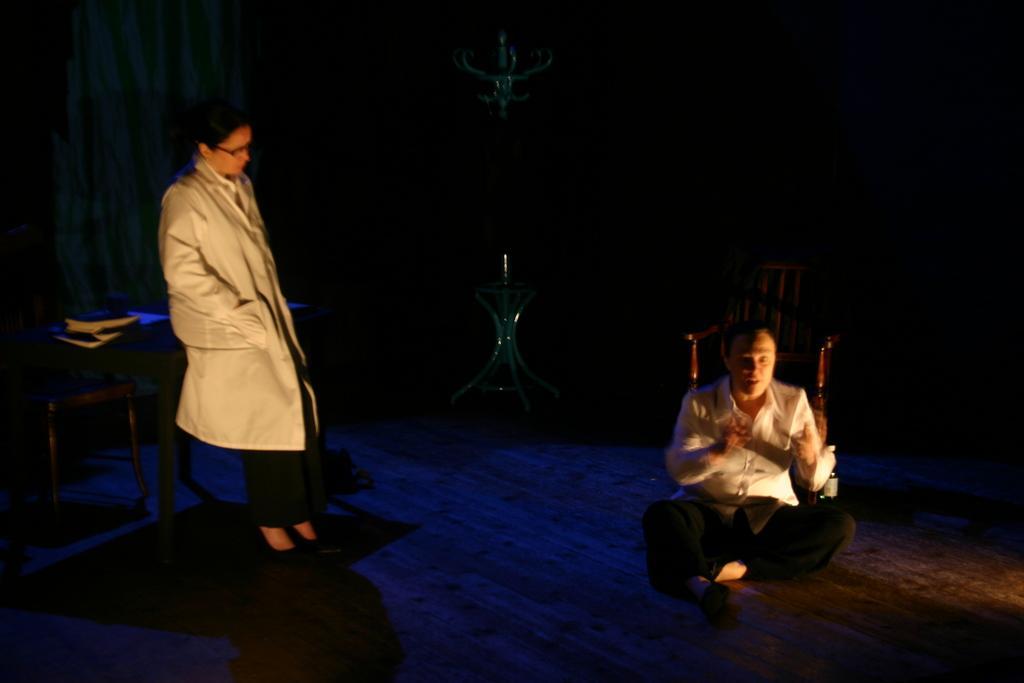Can you describe this image briefly? In this image on the right side there is one person who is sitting, beside him there is one chair. On the left side there is one woman who is standing, beside her there is one table. On the table there are some books and in the center there is one table, on the table there is one glass and on the top of the image there is one light and on the left side there is a curtain. At the bottom there is a floor. 